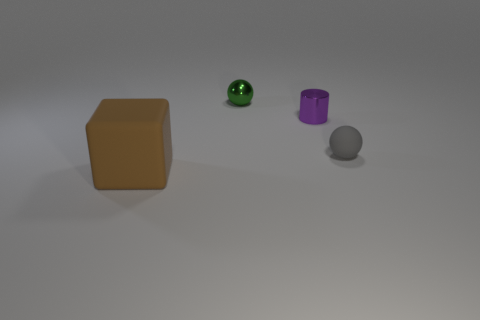Add 4 big red shiny objects. How many objects exist? 8 Subtract all blocks. How many objects are left? 3 Add 3 small green objects. How many small green objects are left? 4 Add 1 large metal things. How many large metal things exist? 1 Subtract 0 blue blocks. How many objects are left? 4 Subtract all tiny purple rubber blocks. Subtract all brown matte cubes. How many objects are left? 3 